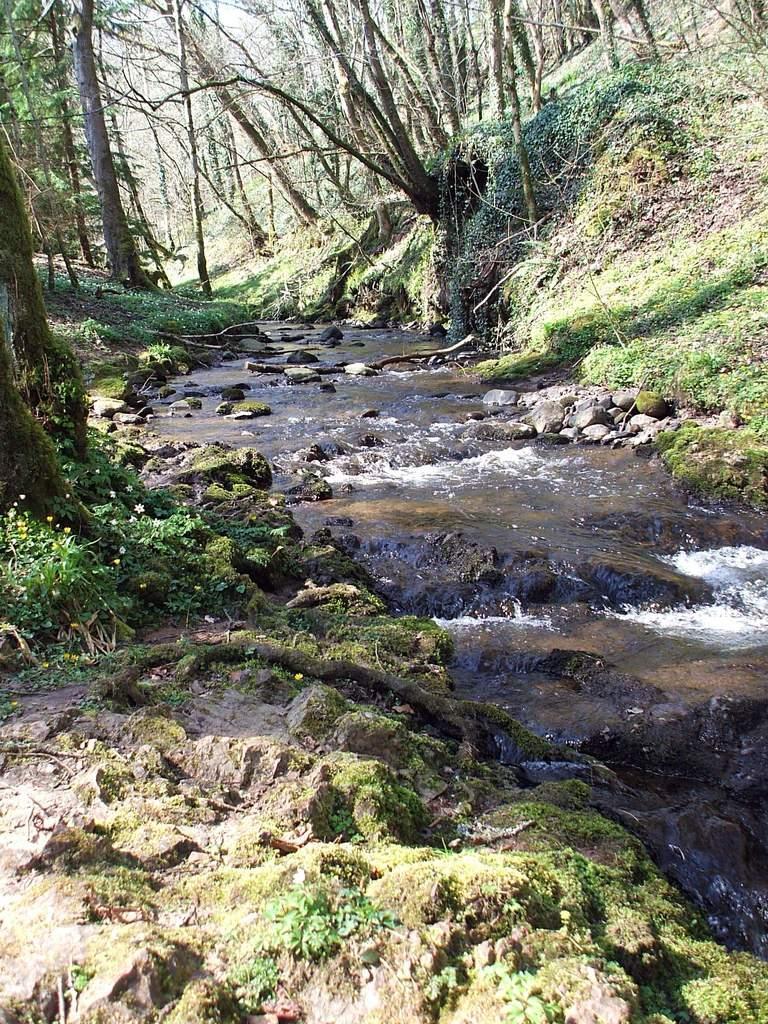Describe this image in one or two sentences. There is a river. Also there are rocks. On the sides there are plants and trees. 